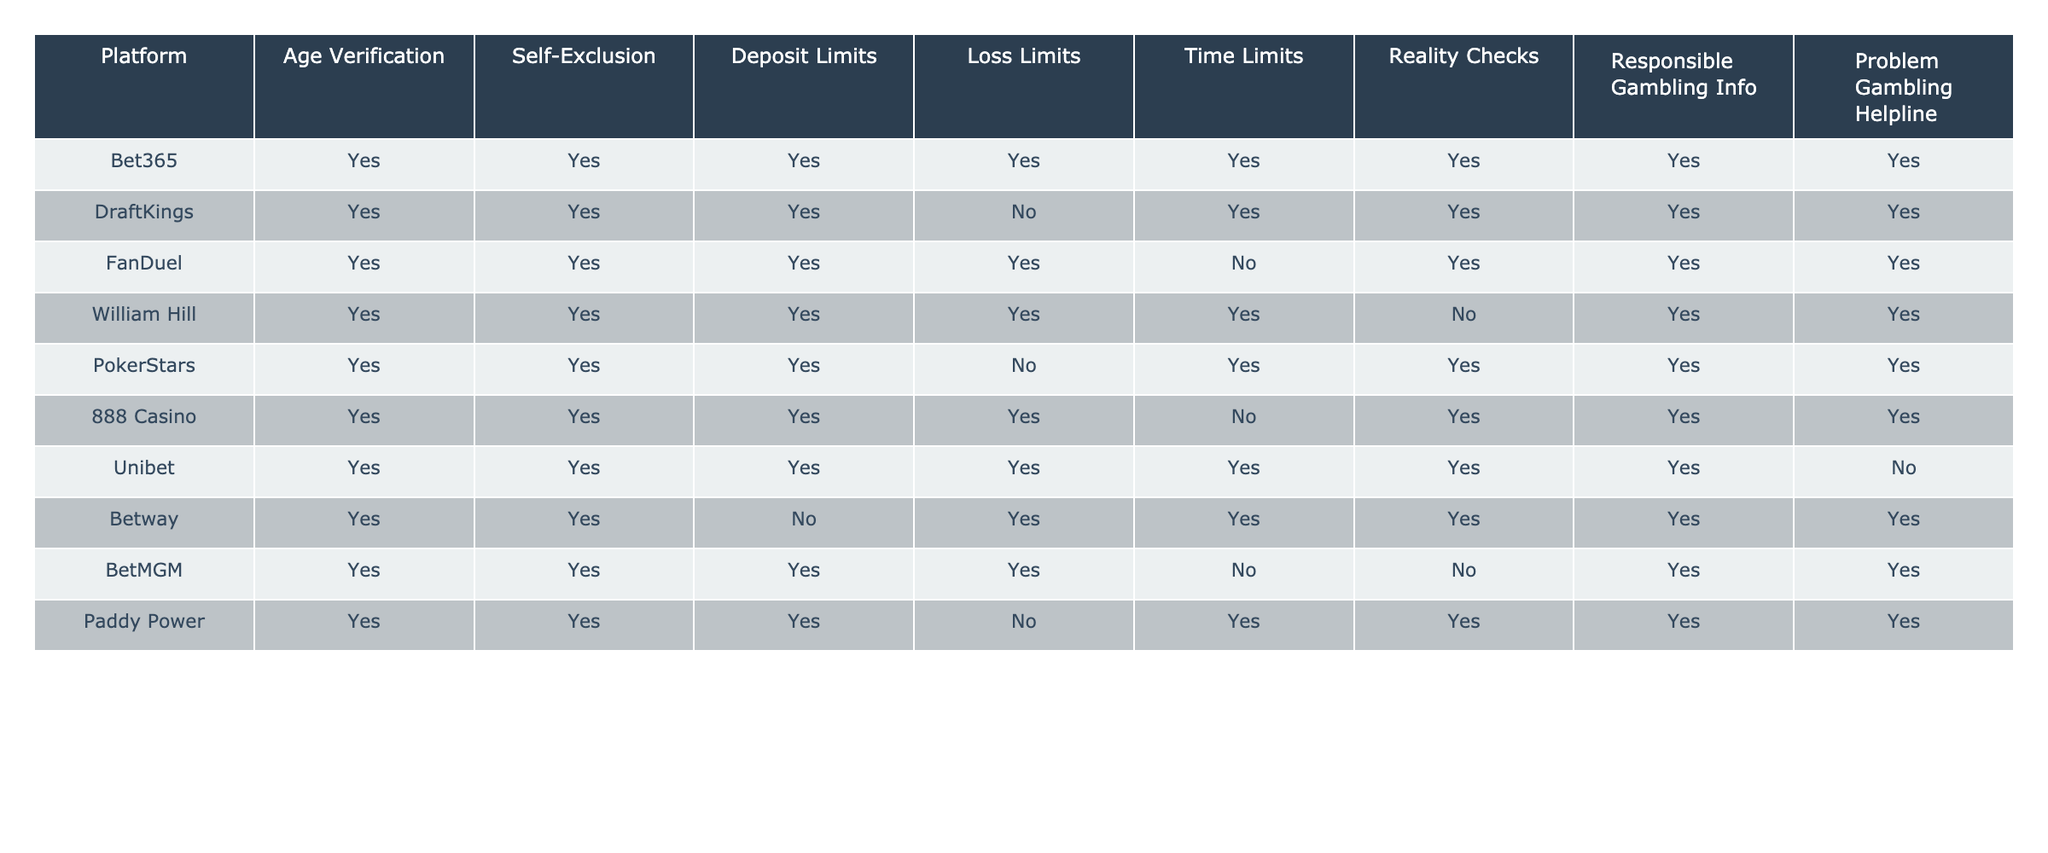What player protection measures does BetWay implement? BetWay implements age verification, self-exclusion, deposit limits, loss limits, time limits, reality checks, and responsible gambling information.
Answer: Yes to all except deposit limits How many platforms offer time limits as a player protection measure? By counting the 'Yes' responses in the Time Limits column, we see that six platforms (Bet365, DraftKings, FanDuel, William Hill, Paddy Power, and Unibet) have implemented this measure.
Answer: Six platforms Which platform does not provide a problem gambling helpline? By looking at the Problem Gambling Helpline column, we find that Unibet is the only platform that does not offer this measure.
Answer: Unibet Do all platforms provide responsible gambling information? Checking the Responsible Gambling Info column, we find that all platforms except for Unibet offer this information.
Answer: No, Unibet does not provide it How many platforms allow self-exclusion as a player protection measure? There are 10 platforms listed in the table, and all 10 have implemented self-exclusion policies.
Answer: Ten platforms Is there a platform that offers loss limits but does not have deposit limits? Examining the Loss Limits and Deposit Limits columns, we find that Betway allows loss limits but does not implement deposit limits.
Answer: Yes, Betway What percentage of platforms implement both age verification and reality checks? Out of the 10 platforms, all implement age verification (10/10) and six provide reality checks (6/10). Therefore, (6/10) * 100 = 60%.
Answer: 60% Which platform has the least number of implemented measures? By reviewing the columns, we see that BetMGM has two 'No' responses, representing the fewest measures.
Answer: BetMGM How does the number of platforms offering deposit limits compare to those that have loss limits? Eight platforms have implemented deposit limits, while all 10 platforms have loss limits. The difference is 2 platforms.
Answer: Two platforms more offer loss limits Which two platforms have similar protections but differ in their provision of loss limits? Looking at the table, PokerStars and 888 Casino both have similar protections but differ in that PokerStars does not implement loss limits while 888 Casino does.
Answer: PokerStars and 888 Casino 